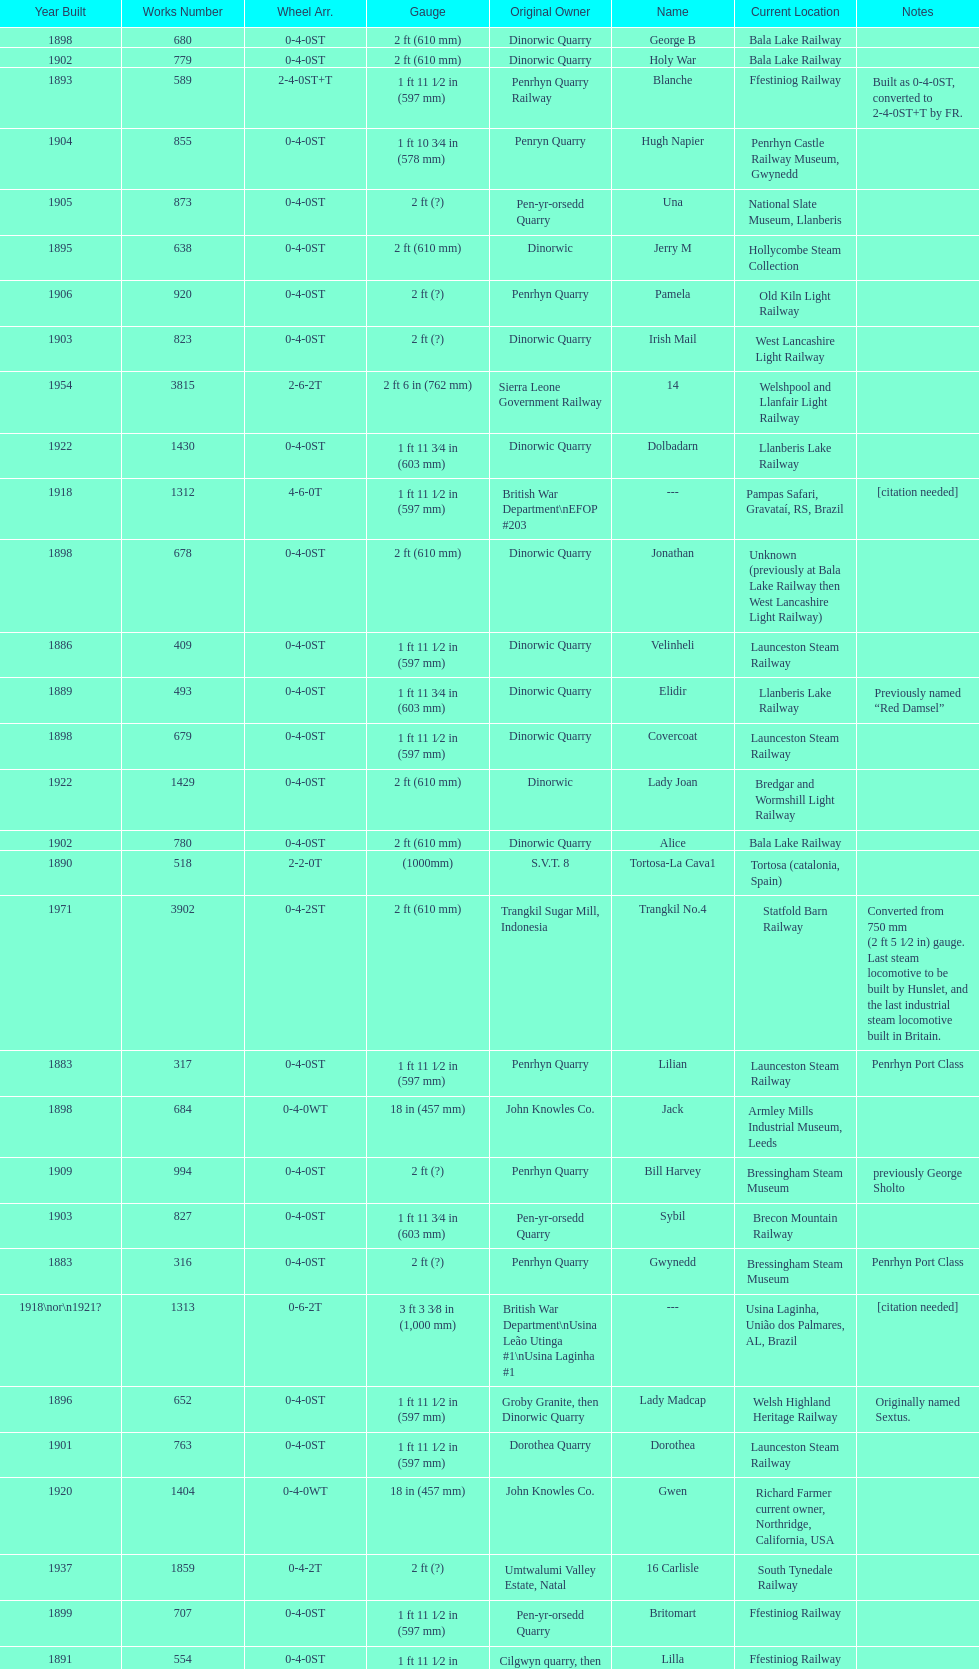What is the total number of preserved hunslet narrow gauge locomotives currently located in ffestiniog railway 554. 